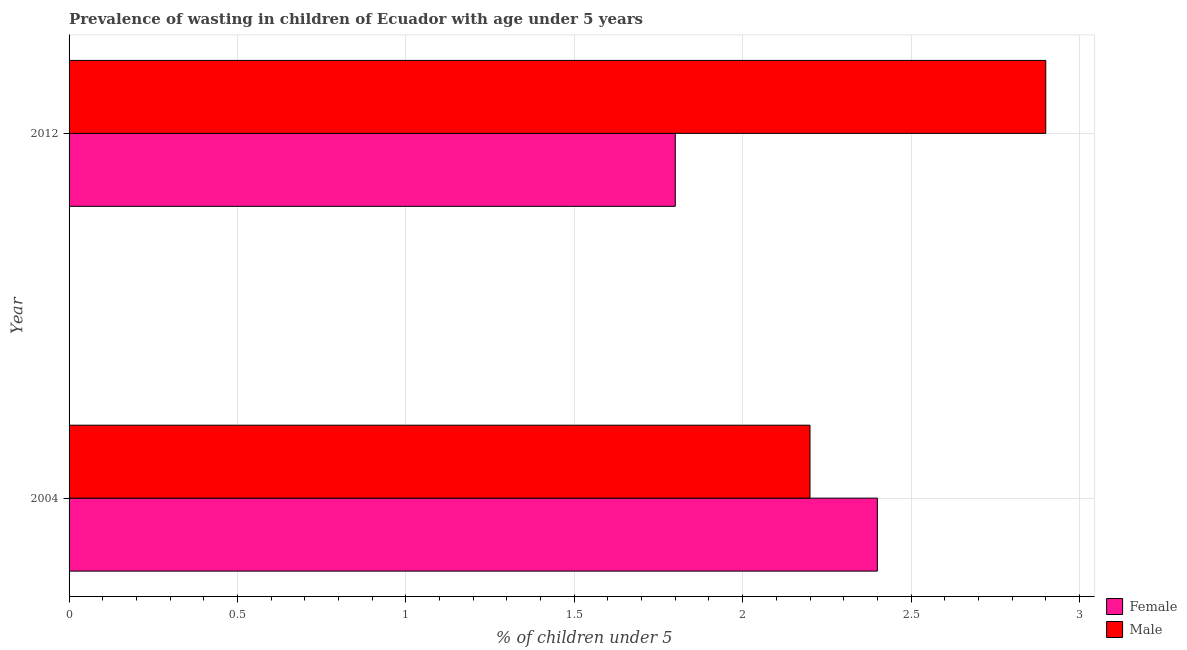How many different coloured bars are there?
Your answer should be very brief. 2. Are the number of bars per tick equal to the number of legend labels?
Provide a short and direct response. Yes. In how many cases, is the number of bars for a given year not equal to the number of legend labels?
Provide a succinct answer. 0. What is the percentage of undernourished male children in 2004?
Provide a succinct answer. 2.2. Across all years, what is the maximum percentage of undernourished male children?
Offer a very short reply. 2.9. Across all years, what is the minimum percentage of undernourished male children?
Your response must be concise. 2.2. In which year was the percentage of undernourished female children minimum?
Keep it short and to the point. 2012. What is the total percentage of undernourished male children in the graph?
Provide a short and direct response. 5.1. What is the difference between the percentage of undernourished female children in 2012 and the percentage of undernourished male children in 2004?
Offer a very short reply. -0.4. What is the average percentage of undernourished female children per year?
Offer a very short reply. 2.1. What is the ratio of the percentage of undernourished female children in 2004 to that in 2012?
Your answer should be compact. 1.33. What does the 1st bar from the bottom in 2004 represents?
Make the answer very short. Female. How many bars are there?
Keep it short and to the point. 4. Are the values on the major ticks of X-axis written in scientific E-notation?
Your answer should be compact. No. Does the graph contain grids?
Provide a short and direct response. Yes. What is the title of the graph?
Give a very brief answer. Prevalence of wasting in children of Ecuador with age under 5 years. What is the label or title of the X-axis?
Offer a very short reply.  % of children under 5. What is the label or title of the Y-axis?
Keep it short and to the point. Year. What is the  % of children under 5 in Female in 2004?
Your answer should be very brief. 2.4. What is the  % of children under 5 in Male in 2004?
Your response must be concise. 2.2. What is the  % of children under 5 in Female in 2012?
Provide a succinct answer. 1.8. What is the  % of children under 5 of Male in 2012?
Provide a succinct answer. 2.9. Across all years, what is the maximum  % of children under 5 of Female?
Your answer should be compact. 2.4. Across all years, what is the maximum  % of children under 5 in Male?
Keep it short and to the point. 2.9. Across all years, what is the minimum  % of children under 5 in Female?
Give a very brief answer. 1.8. Across all years, what is the minimum  % of children under 5 of Male?
Make the answer very short. 2.2. What is the total  % of children under 5 of Female in the graph?
Your response must be concise. 4.2. What is the total  % of children under 5 of Male in the graph?
Provide a short and direct response. 5.1. What is the difference between the  % of children under 5 in Female in 2004 and the  % of children under 5 in Male in 2012?
Make the answer very short. -0.5. What is the average  % of children under 5 of Female per year?
Ensure brevity in your answer.  2.1. What is the average  % of children under 5 in Male per year?
Your answer should be very brief. 2.55. In the year 2004, what is the difference between the  % of children under 5 of Female and  % of children under 5 of Male?
Keep it short and to the point. 0.2. In the year 2012, what is the difference between the  % of children under 5 in Female and  % of children under 5 in Male?
Make the answer very short. -1.1. What is the ratio of the  % of children under 5 of Female in 2004 to that in 2012?
Keep it short and to the point. 1.33. What is the ratio of the  % of children under 5 in Male in 2004 to that in 2012?
Offer a terse response. 0.76. What is the difference between the highest and the second highest  % of children under 5 of Female?
Keep it short and to the point. 0.6. 